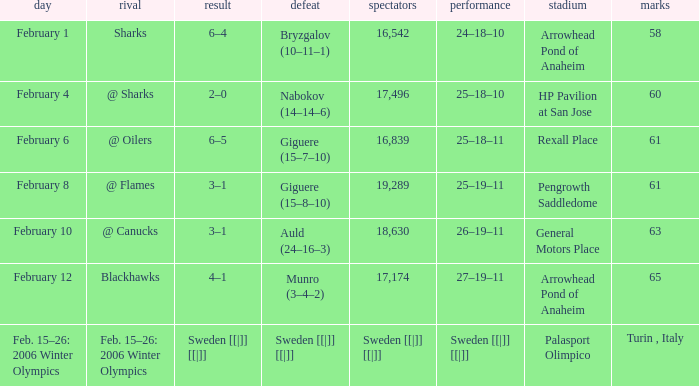What is the record when the score was 2–0? 25–18–10. 